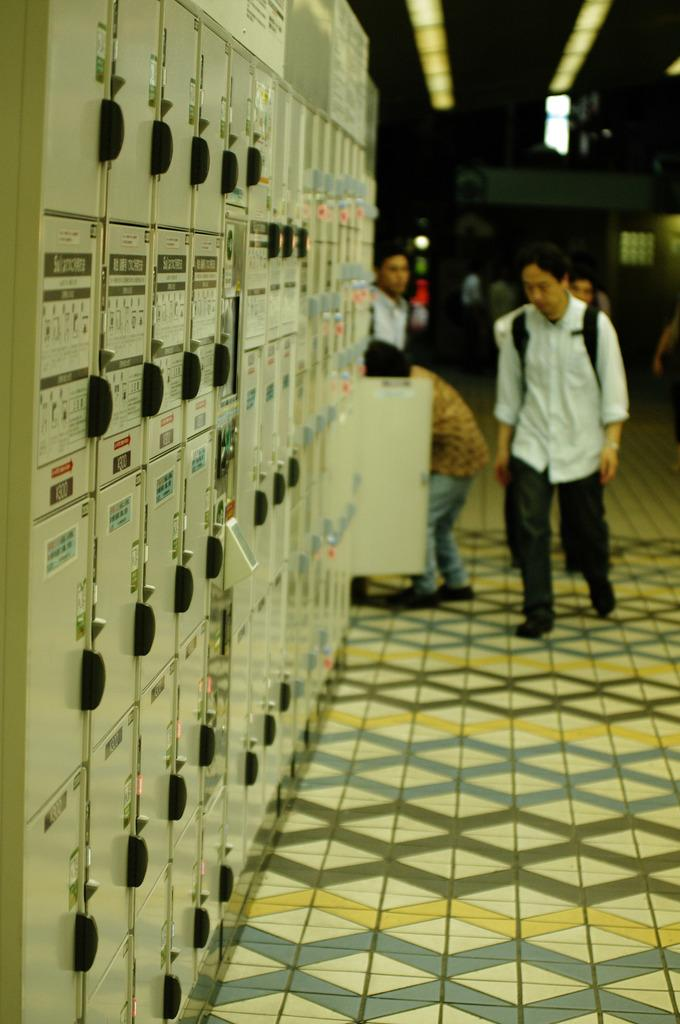What can be seen in the image related to people? There are persons wearing clothes in the image. What is located on the left side of the image? There is a panel board on the left side of the image. What can be seen in the top right of the image? There are lights in the top right of the image. How many geese are visible in the image? There are no geese present in the image. What type of match is being played in the image? There is no match being played in the image; it does not depict any sports or games. 